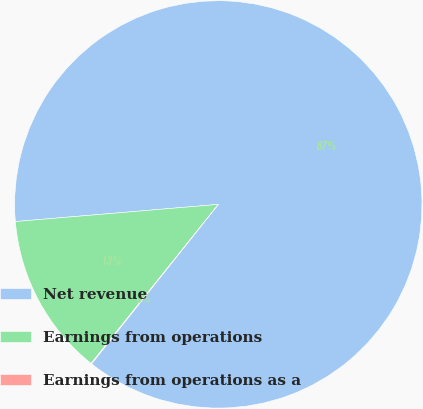Convert chart to OTSL. <chart><loc_0><loc_0><loc_500><loc_500><pie_chart><fcel>Net revenue<fcel>Earnings from operations<fcel>Earnings from operations as a<nl><fcel>87.03%<fcel>12.92%<fcel>0.05%<nl></chart> 